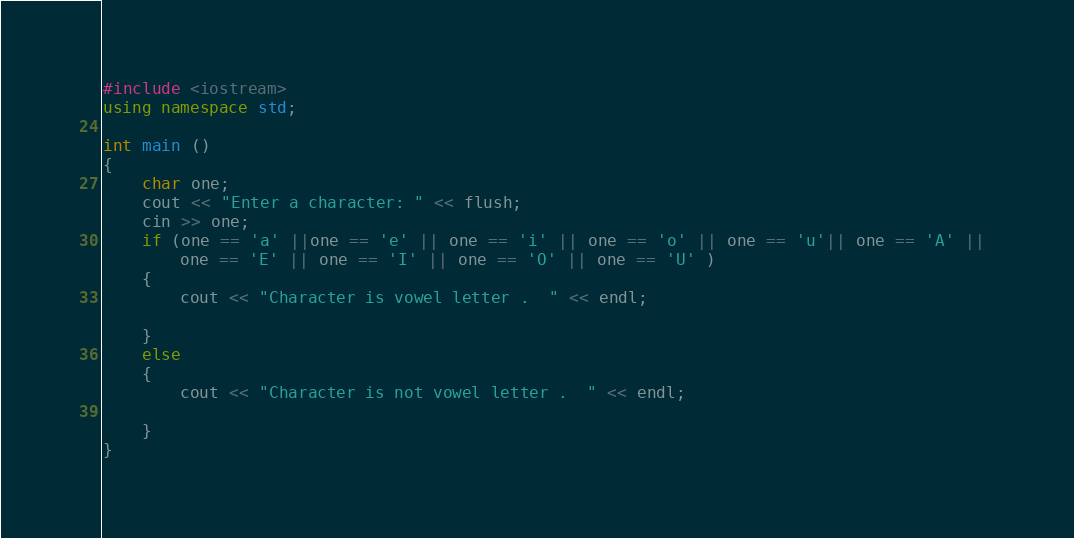Convert code to text. <code><loc_0><loc_0><loc_500><loc_500><_C++_>#include <iostream>
using namespace std;

int main ()
{
    char one;
    cout << "Enter a character: " << flush;
    cin >> one;
    if (one == 'a' ||one == 'e' || one == 'i' || one == 'o' || one == 'u'|| one == 'A' || 
        one == 'E' || one == 'I' || one == 'O' || one == 'U' )
    {
        cout << "Character is vowel letter .  " << endl;

    }
    else
    {
        cout << "Character is not vowel letter .  " << endl;

    }
}</code> 